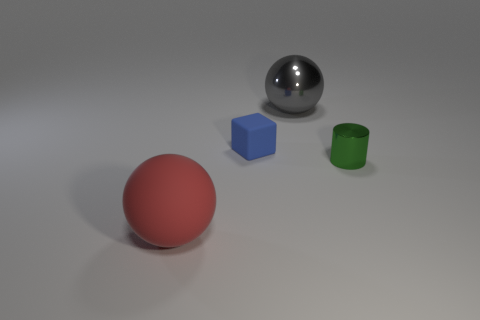Add 4 big gray spheres. How many objects exist? 8 Subtract all cylinders. How many objects are left? 3 Add 4 metallic balls. How many metallic balls are left? 5 Add 1 small blue metallic objects. How many small blue metallic objects exist? 1 Subtract 0 purple cylinders. How many objects are left? 4 Subtract all big gray spheres. Subtract all tiny things. How many objects are left? 1 